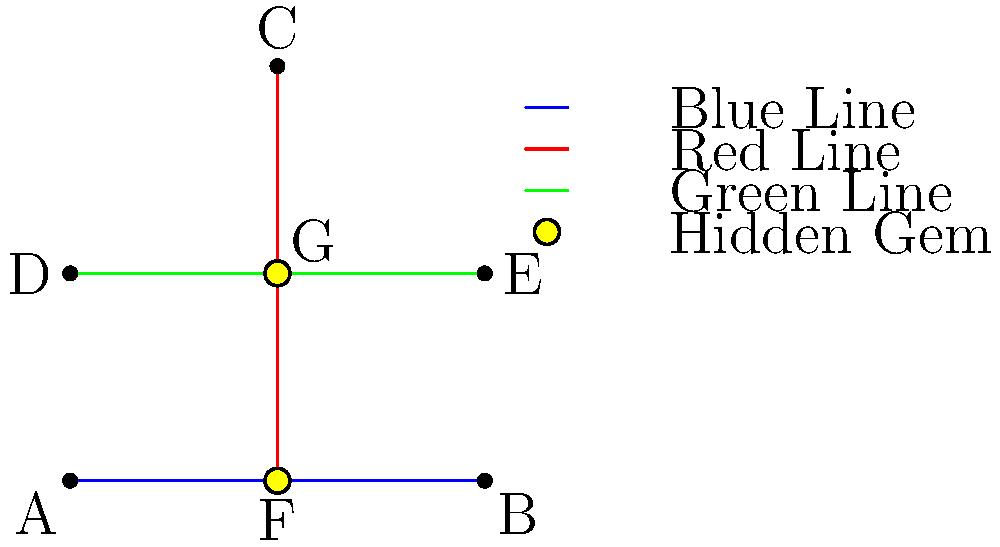Based on the simplified Paris Metro map shown, which two stations are highlighted as hidden gems, and how many different metro lines can tourists use to travel between these two hidden gem stations? To answer this question, we need to follow these steps:

1. Identify the highlighted stations (hidden gems):
   - Station F on the blue line
   - Station G at the intersection of the red and green lines

2. Count the number of different metro lines connecting these stations:
   - Blue line: directly connects F and G
   - Red line: connects F and G (passengers need to change at G)
   - Green line: connects F and G (passengers need to change at G)

3. Sum up the number of different lines:
   There are 3 different metro lines that tourists can use to travel between the two hidden gem stations (F and G).
Answer: Stations F and G; 3 lines 